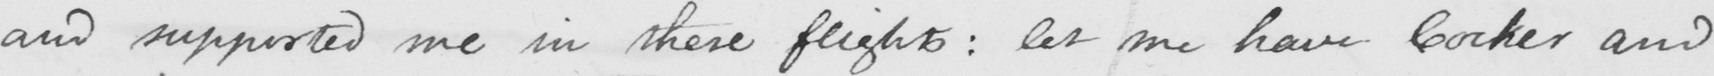Can you tell me what this handwritten text says? and supported me in these flights :  let me have Cocker and 